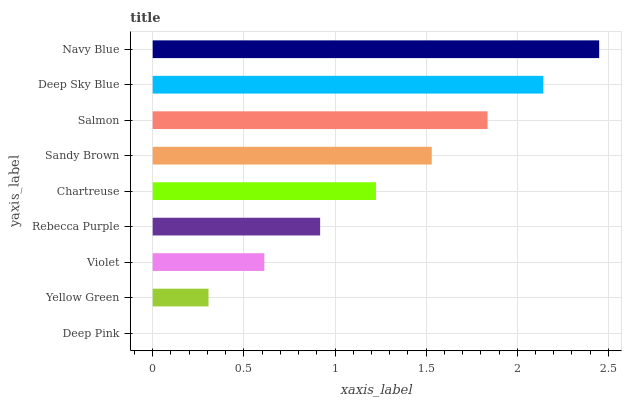Is Deep Pink the minimum?
Answer yes or no. Yes. Is Navy Blue the maximum?
Answer yes or no. Yes. Is Yellow Green the minimum?
Answer yes or no. No. Is Yellow Green the maximum?
Answer yes or no. No. Is Yellow Green greater than Deep Pink?
Answer yes or no. Yes. Is Deep Pink less than Yellow Green?
Answer yes or no. Yes. Is Deep Pink greater than Yellow Green?
Answer yes or no. No. Is Yellow Green less than Deep Pink?
Answer yes or no. No. Is Chartreuse the high median?
Answer yes or no. Yes. Is Chartreuse the low median?
Answer yes or no. Yes. Is Navy Blue the high median?
Answer yes or no. No. Is Violet the low median?
Answer yes or no. No. 